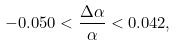Convert formula to latex. <formula><loc_0><loc_0><loc_500><loc_500>- 0 . 0 5 0 < \frac { \Delta \alpha } { \alpha } < 0 . 0 4 2 ,</formula> 